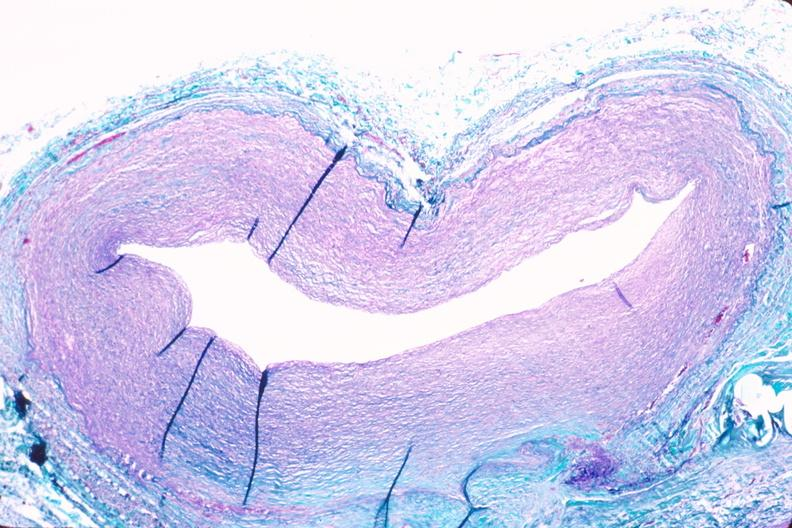where is this in?
Answer the question using a single word or phrase. In vasculature 